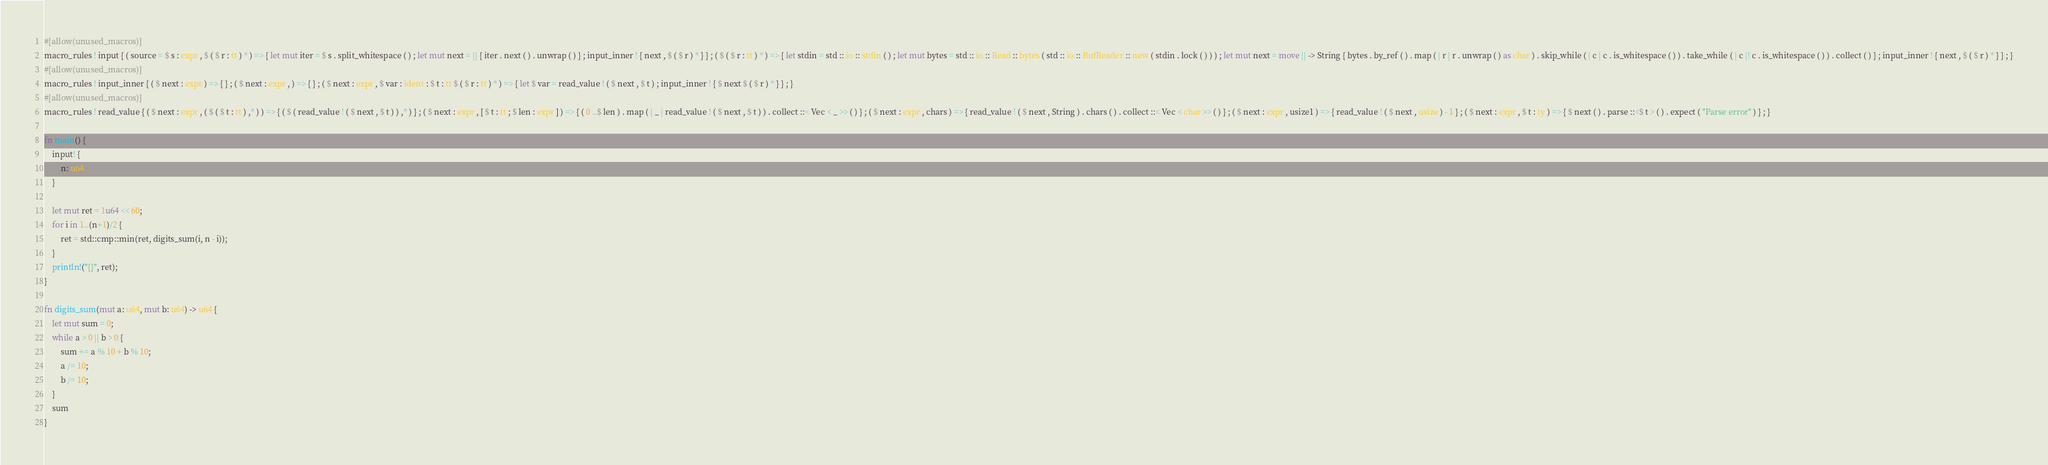Convert code to text. <code><loc_0><loc_0><loc_500><loc_500><_Rust_>#[allow(unused_macros)]
macro_rules ! input { ( source = $ s : expr , $ ( $ r : tt ) * ) => { let mut iter = $ s . split_whitespace ( ) ; let mut next = || { iter . next ( ) . unwrap ( ) } ; input_inner ! { next , $ ( $ r ) * } } ; ( $ ( $ r : tt ) * ) => { let stdin = std :: io :: stdin ( ) ; let mut bytes = std :: io :: Read :: bytes ( std :: io :: BufReader :: new ( stdin . lock ( ) ) ) ; let mut next = move || -> String { bytes . by_ref ( ) . map ( | r | r . unwrap ( ) as char ) . skip_while ( | c | c . is_whitespace ( ) ) . take_while ( | c |! c . is_whitespace ( ) ) . collect ( ) } ; input_inner ! { next , $ ( $ r ) * } } ; }
#[allow(unused_macros)]
macro_rules ! input_inner { ( $ next : expr ) => { } ; ( $ next : expr , ) => { } ; ( $ next : expr , $ var : ident : $ t : tt $ ( $ r : tt ) * ) => { let $ var = read_value ! ( $ next , $ t ) ; input_inner ! { $ next $ ( $ r ) * } } ; }
#[allow(unused_macros)]
macro_rules ! read_value { ( $ next : expr , ( $ ( $ t : tt ) ,* ) ) => { ( $ ( read_value ! ( $ next , $ t ) ) ,* ) } ; ( $ next : expr , [ $ t : tt ; $ len : expr ] ) => { ( 0 ..$ len ) . map ( | _ | read_value ! ( $ next , $ t ) ) . collect ::< Vec < _ >> ( ) } ; ( $ next : expr , chars ) => { read_value ! ( $ next , String ) . chars ( ) . collect ::< Vec < char >> ( ) } ; ( $ next : expr , usize1 ) => { read_value ! ( $ next , usize ) - 1 } ; ( $ next : expr , $ t : ty ) => { $ next ( ) . parse ::<$ t > ( ) . expect ( "Parse error" ) } ; }

fn main() {
    input! {
        n: u64
    }

    let mut ret = 1u64 << 60;
    for i in 1..(n+1)/2 {
        ret = std::cmp::min(ret, digits_sum(i, n - i));
    }
    println!("{}", ret);
}

fn digits_sum(mut a: u64, mut b: u64) -> u64 {
    let mut sum = 0;
    while a > 0 || b > 0 {
        sum += a % 10 + b % 10;
        a /= 10;
        b /= 10;
    }
    sum
}
</code> 